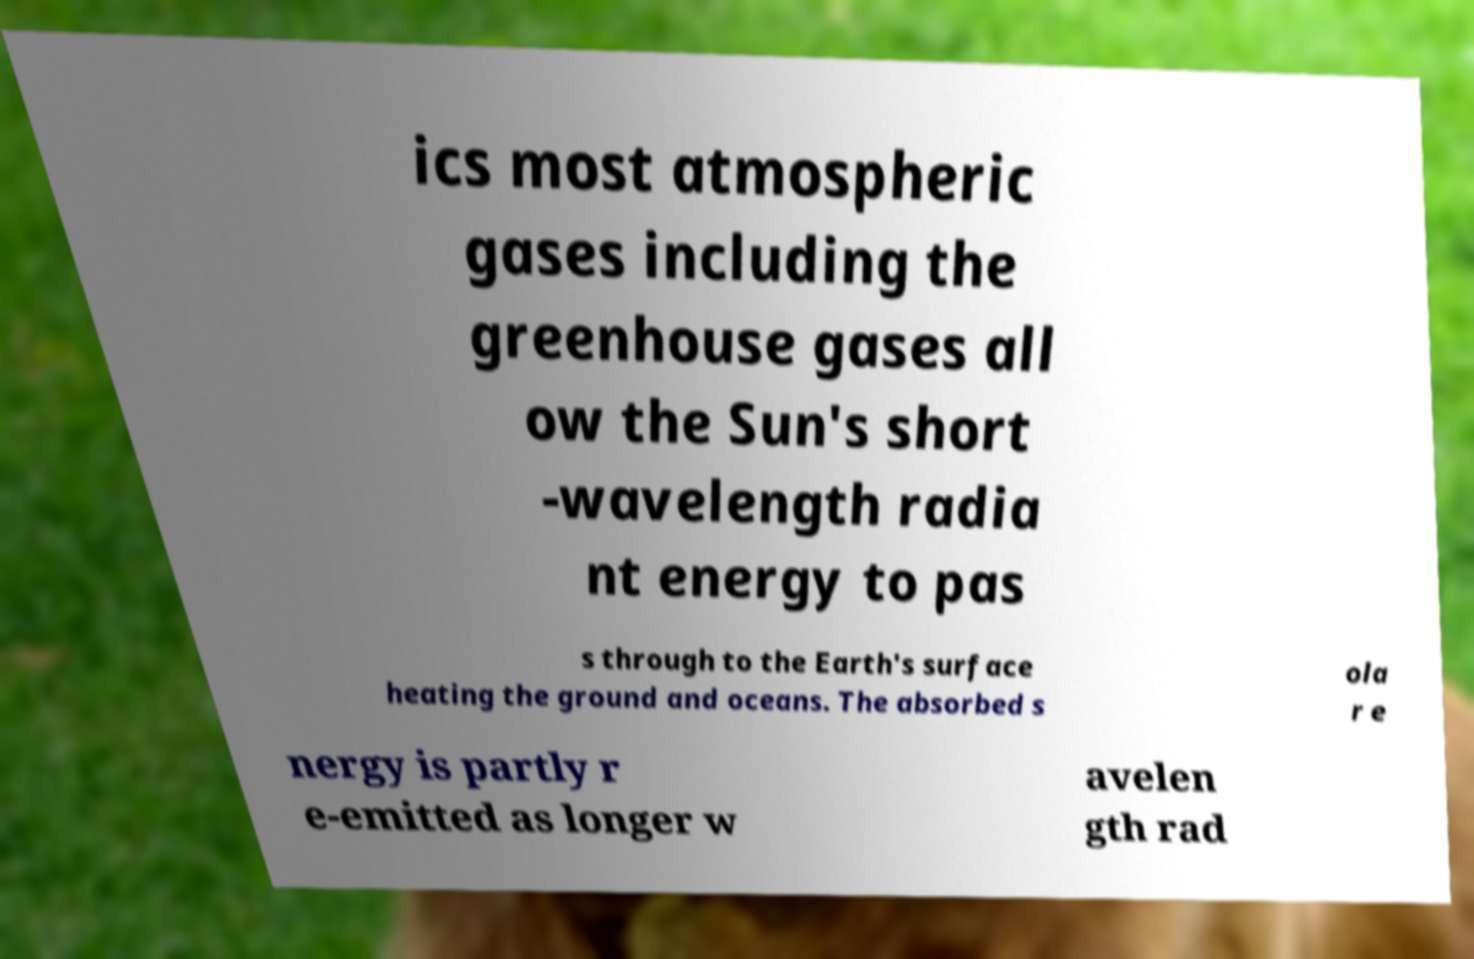For documentation purposes, I need the text within this image transcribed. Could you provide that? ics most atmospheric gases including the greenhouse gases all ow the Sun's short -wavelength radia nt energy to pas s through to the Earth's surface heating the ground and oceans. The absorbed s ola r e nergy is partly r e-emitted as longer w avelen gth rad 